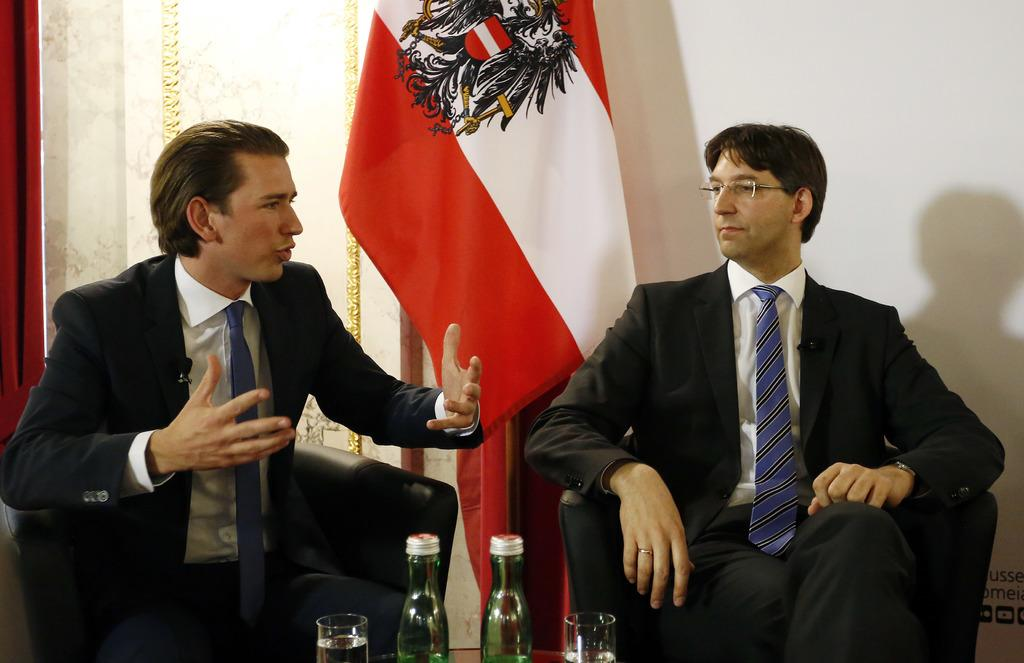How many people are in the image? There are two persons in the image. What are the people in the image doing? One person is talking with another person. What can be seen in the middle of the image? There is a flag in the middle of the image. What type of knife is being used by the scarecrow in the image? There is no scarecrow or knife present in the image. 